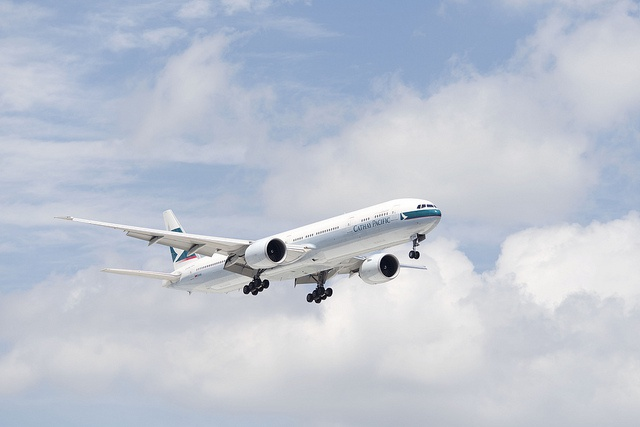Describe the objects in this image and their specific colors. I can see a airplane in darkgray, lightgray, black, and gray tones in this image. 